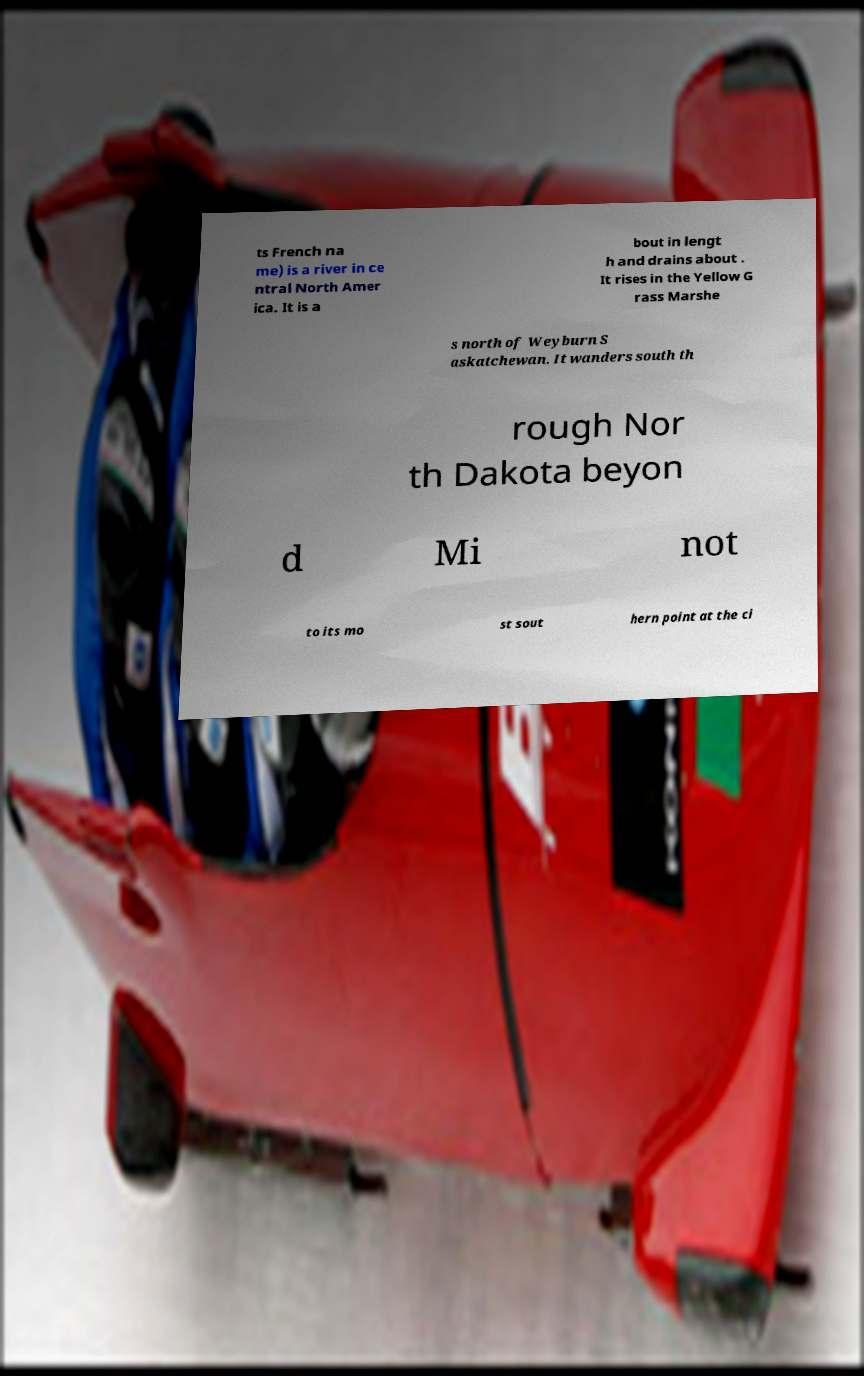Could you extract and type out the text from this image? ts French na me) is a river in ce ntral North Amer ica. It is a bout in lengt h and drains about . It rises in the Yellow G rass Marshe s north of Weyburn S askatchewan. It wanders south th rough Nor th Dakota beyon d Mi not to its mo st sout hern point at the ci 